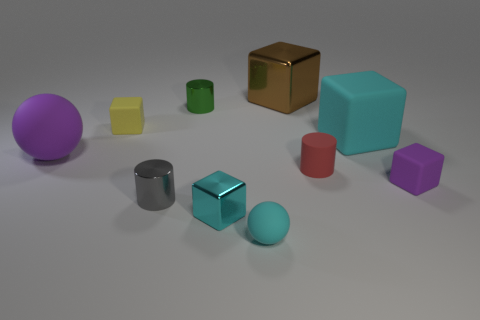There is a small cube that is the same color as the tiny rubber ball; what material is it?
Make the answer very short. Metal. What number of other objects are the same shape as the green shiny object?
Make the answer very short. 2. Is there a large green rubber sphere?
Your response must be concise. No. Is there a tiny cyan thing that has the same material as the small gray cylinder?
Ensure brevity in your answer.  Yes. What is the material of the gray thing that is the same size as the green thing?
Ensure brevity in your answer.  Metal. What number of purple matte things have the same shape as the small cyan rubber object?
Provide a succinct answer. 1. The yellow cube that is the same material as the red object is what size?
Your answer should be compact. Small. What material is the small cylinder that is in front of the big rubber ball and behind the tiny purple matte cube?
Provide a short and direct response. Rubber. How many gray metallic objects are the same size as the red thing?
Keep it short and to the point. 1. There is a small cyan thing that is the same shape as the big cyan matte object; what is it made of?
Give a very brief answer. Metal. 